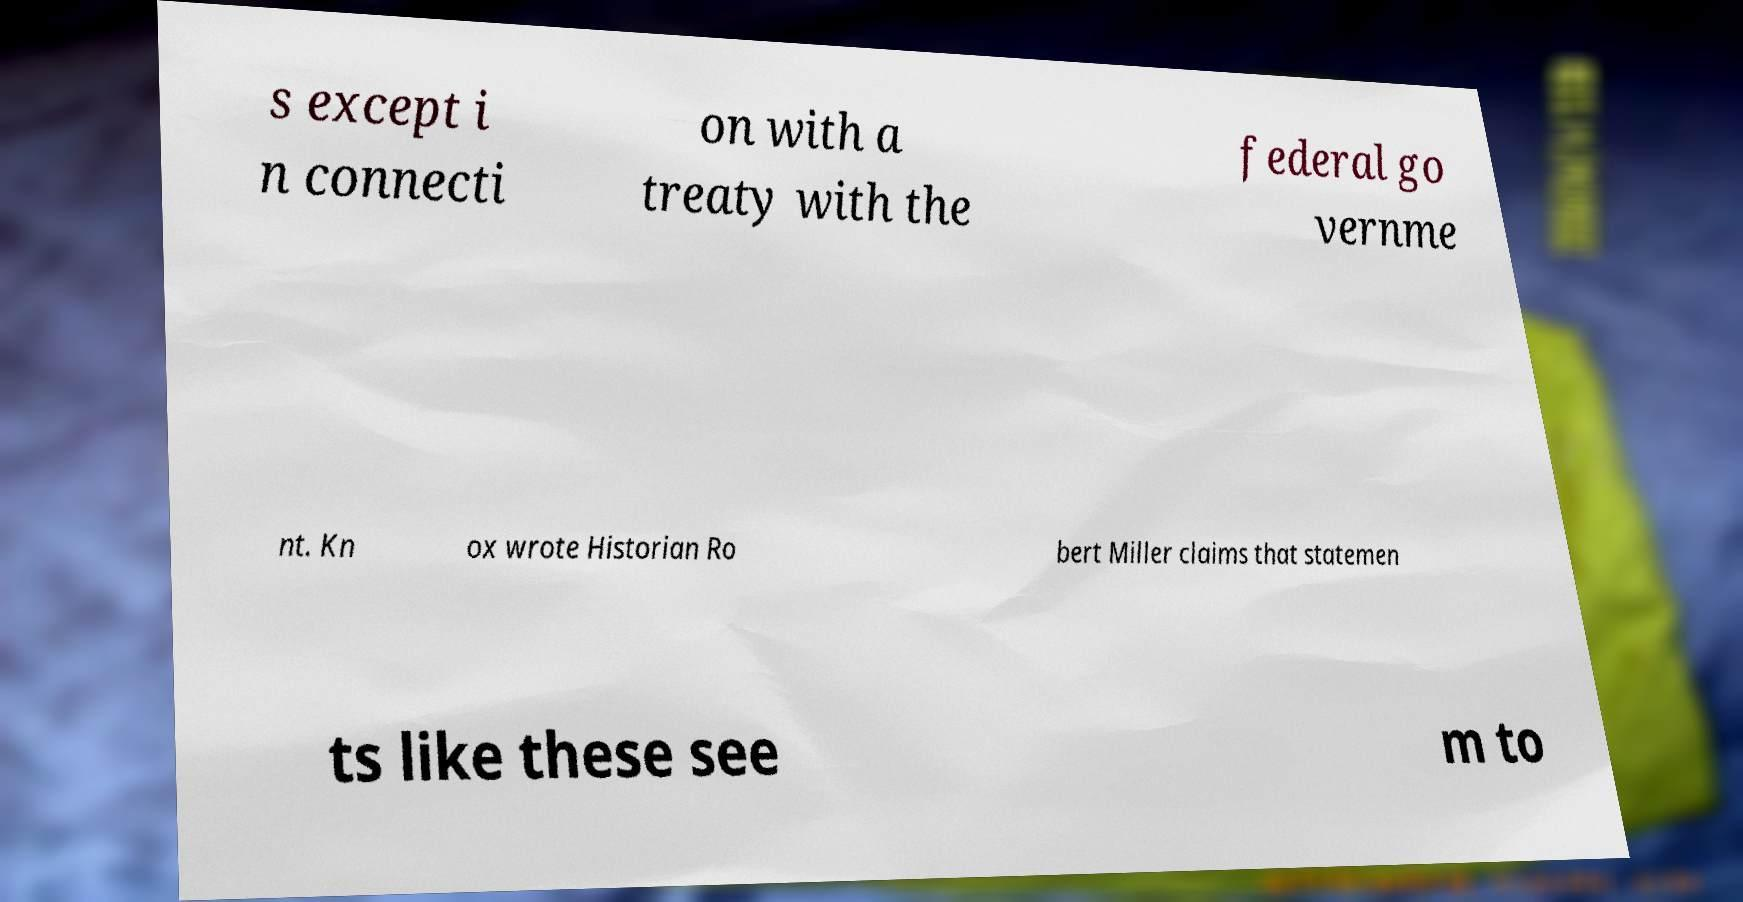What messages or text are displayed in this image? I need them in a readable, typed format. s except i n connecti on with a treaty with the federal go vernme nt. Kn ox wrote Historian Ro bert Miller claims that statemen ts like these see m to 